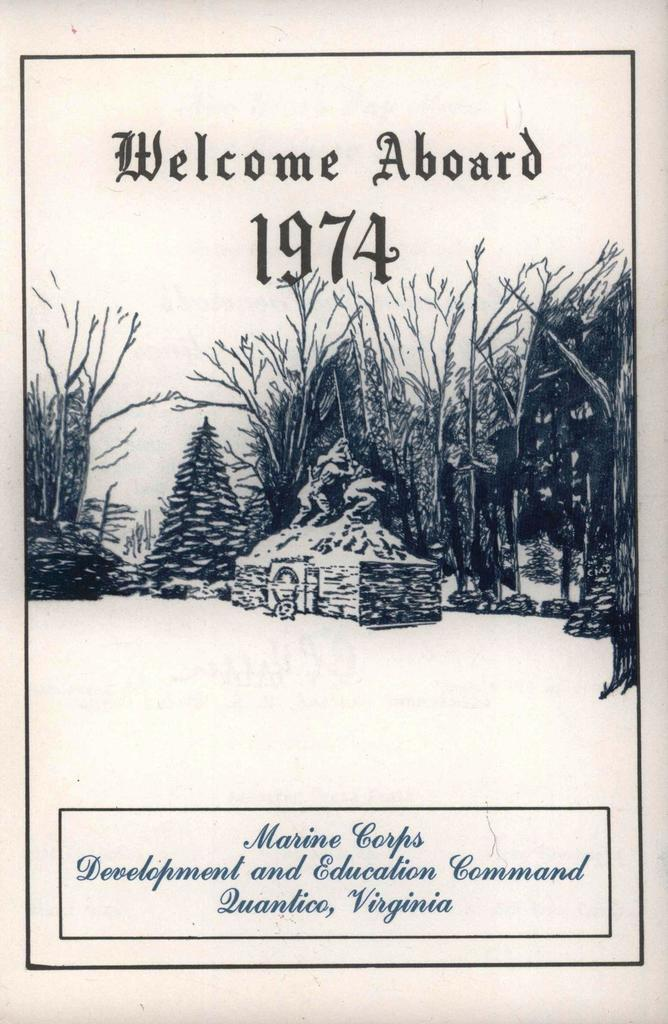What type of visual is depicted in the image? The image is a poster. What natural elements are featured on the poster? There are trees on the poster. What man-made object is present on the poster? There is a statue on the poster. Can you describe the text at the top of the poster? There is text at the top of the poster. What numerical information is included on the poster? There are numbers on the poster. What text can be found at the bottom of the poster? There is text at the bottom of the poster. What type of wool is being used to create the cast of the statue in the image? There is no cast or wool present in the image; it features a poster with a statue and text. 